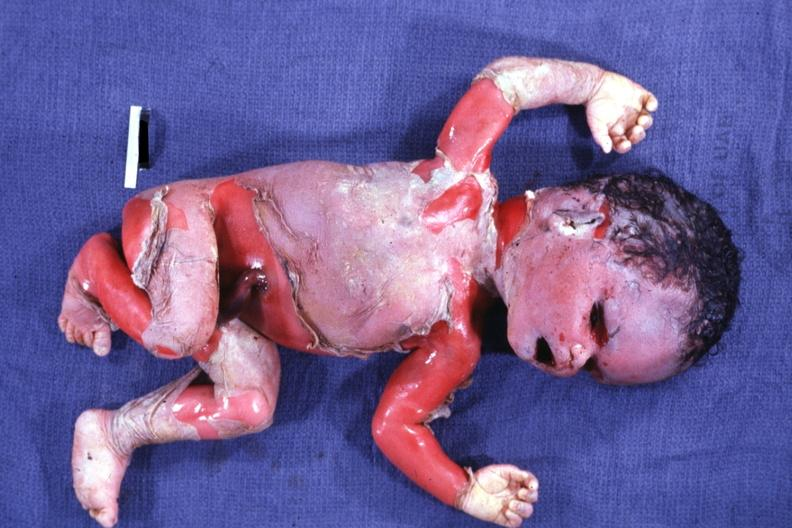what is present?
Answer the question using a single word or phrase. Macerated stillborn 